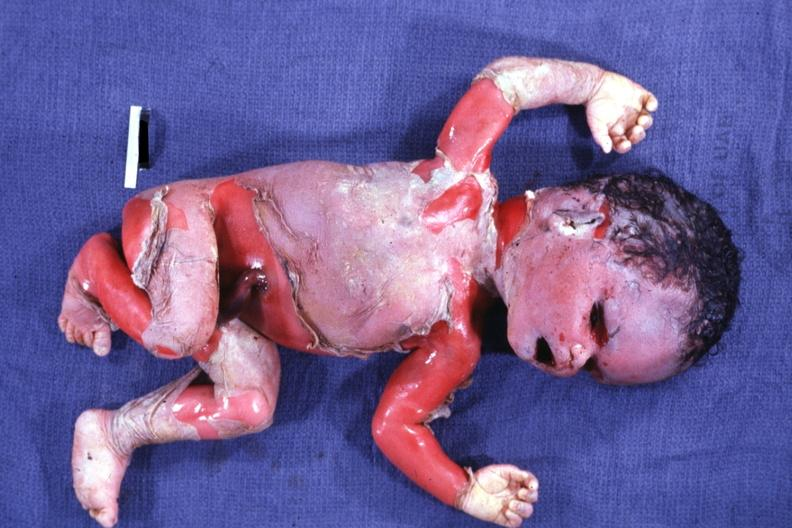what is present?
Answer the question using a single word or phrase. Macerated stillborn 